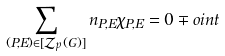Convert formula to latex. <formula><loc_0><loc_0><loc_500><loc_500>\sum _ { ( P , E ) \in [ \mathcal { Z } _ { p } ( G ) ] } n _ { P , E } \chi _ { P , E } = 0 \mp o i n t</formula> 